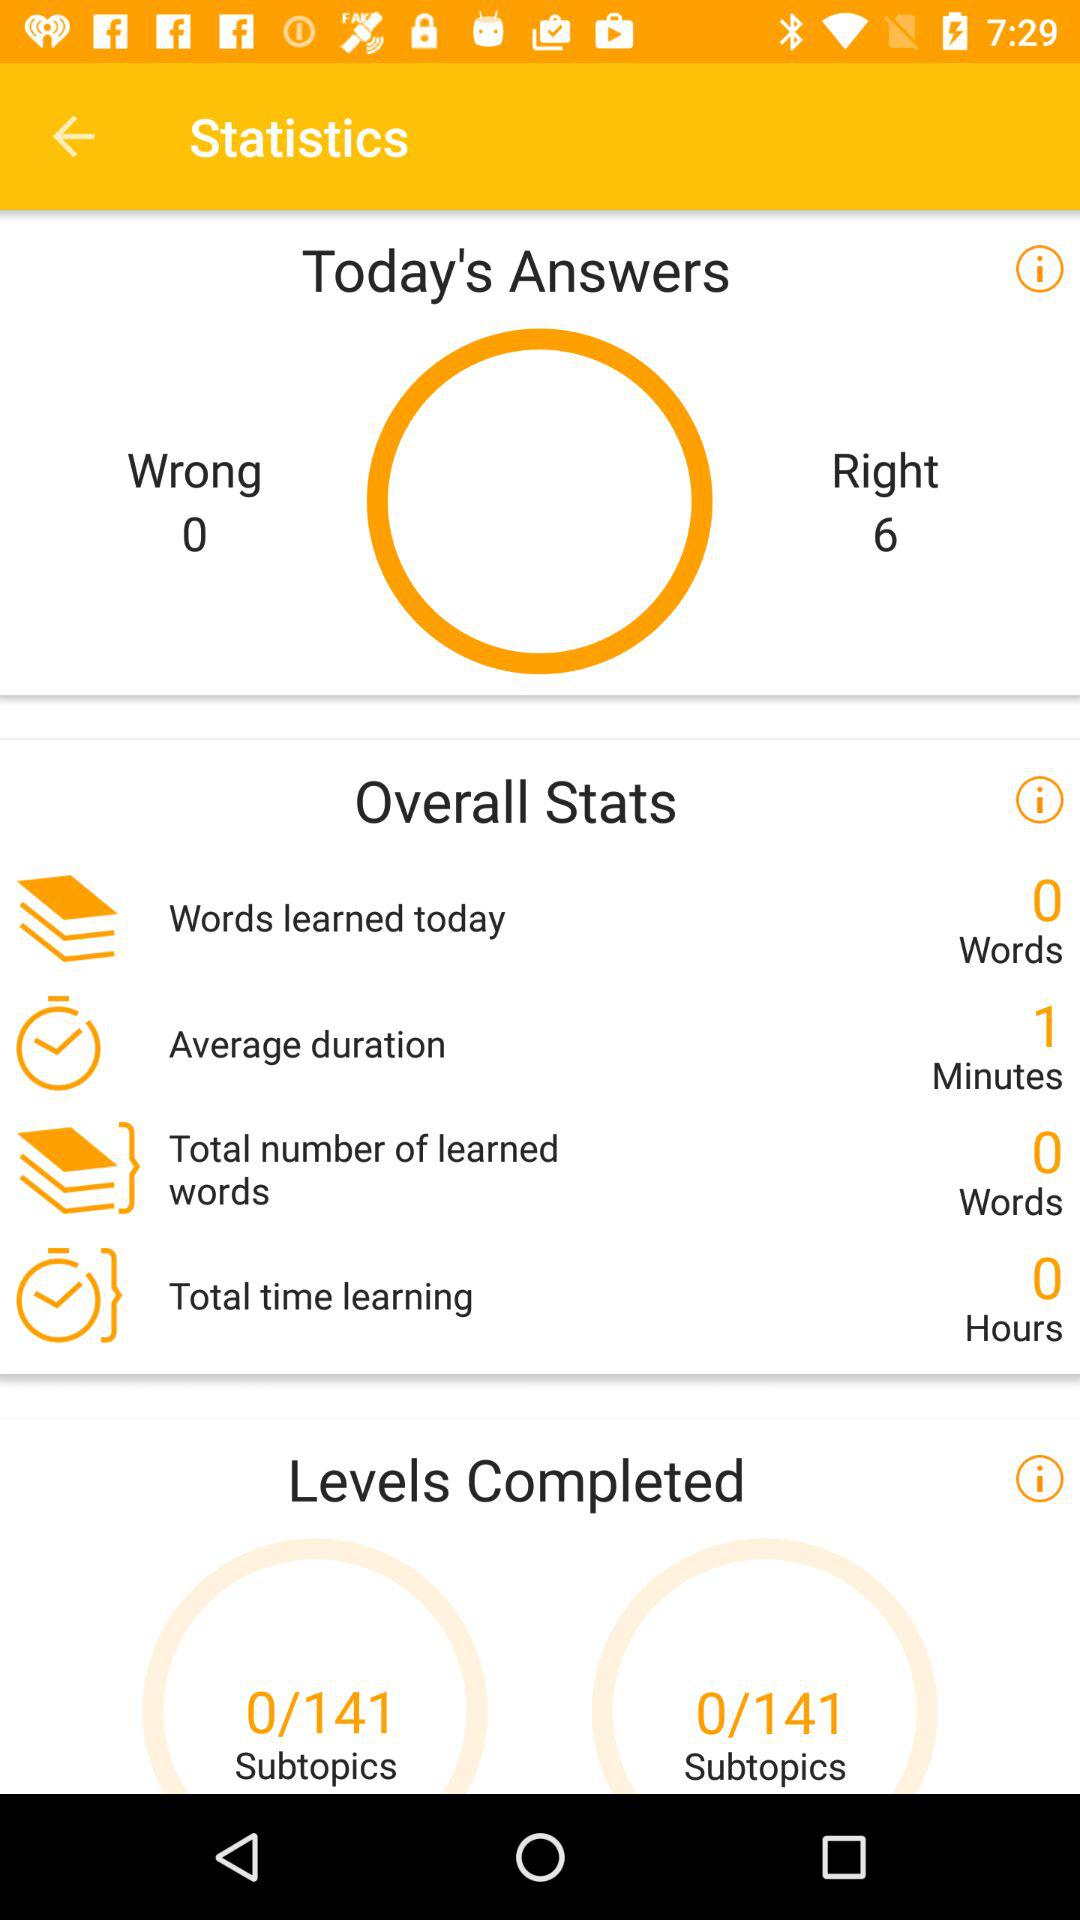How many more right answers than wrong answers are there?
Answer the question using a single word or phrase. 6 